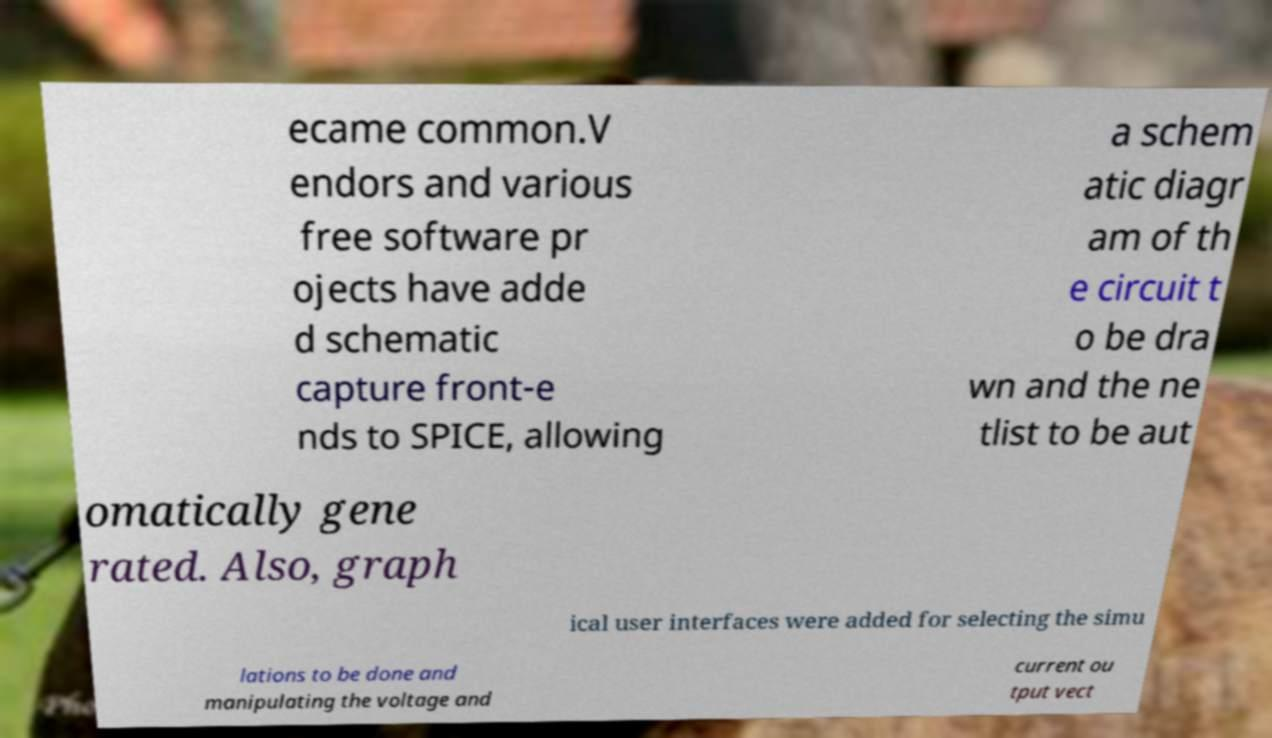For documentation purposes, I need the text within this image transcribed. Could you provide that? ecame common.V endors and various free software pr ojects have adde d schematic capture front-e nds to SPICE, allowing a schem atic diagr am of th e circuit t o be dra wn and the ne tlist to be aut omatically gene rated. Also, graph ical user interfaces were added for selecting the simu lations to be done and manipulating the voltage and current ou tput vect 